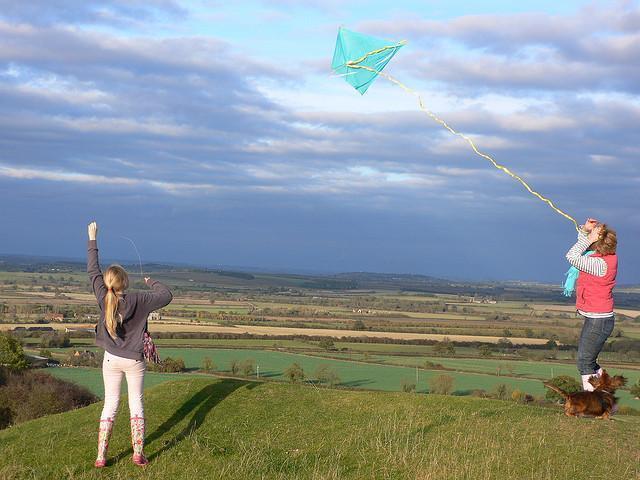How many people are in the picture?
Give a very brief answer. 2. How many red bikes are there?
Give a very brief answer. 0. 